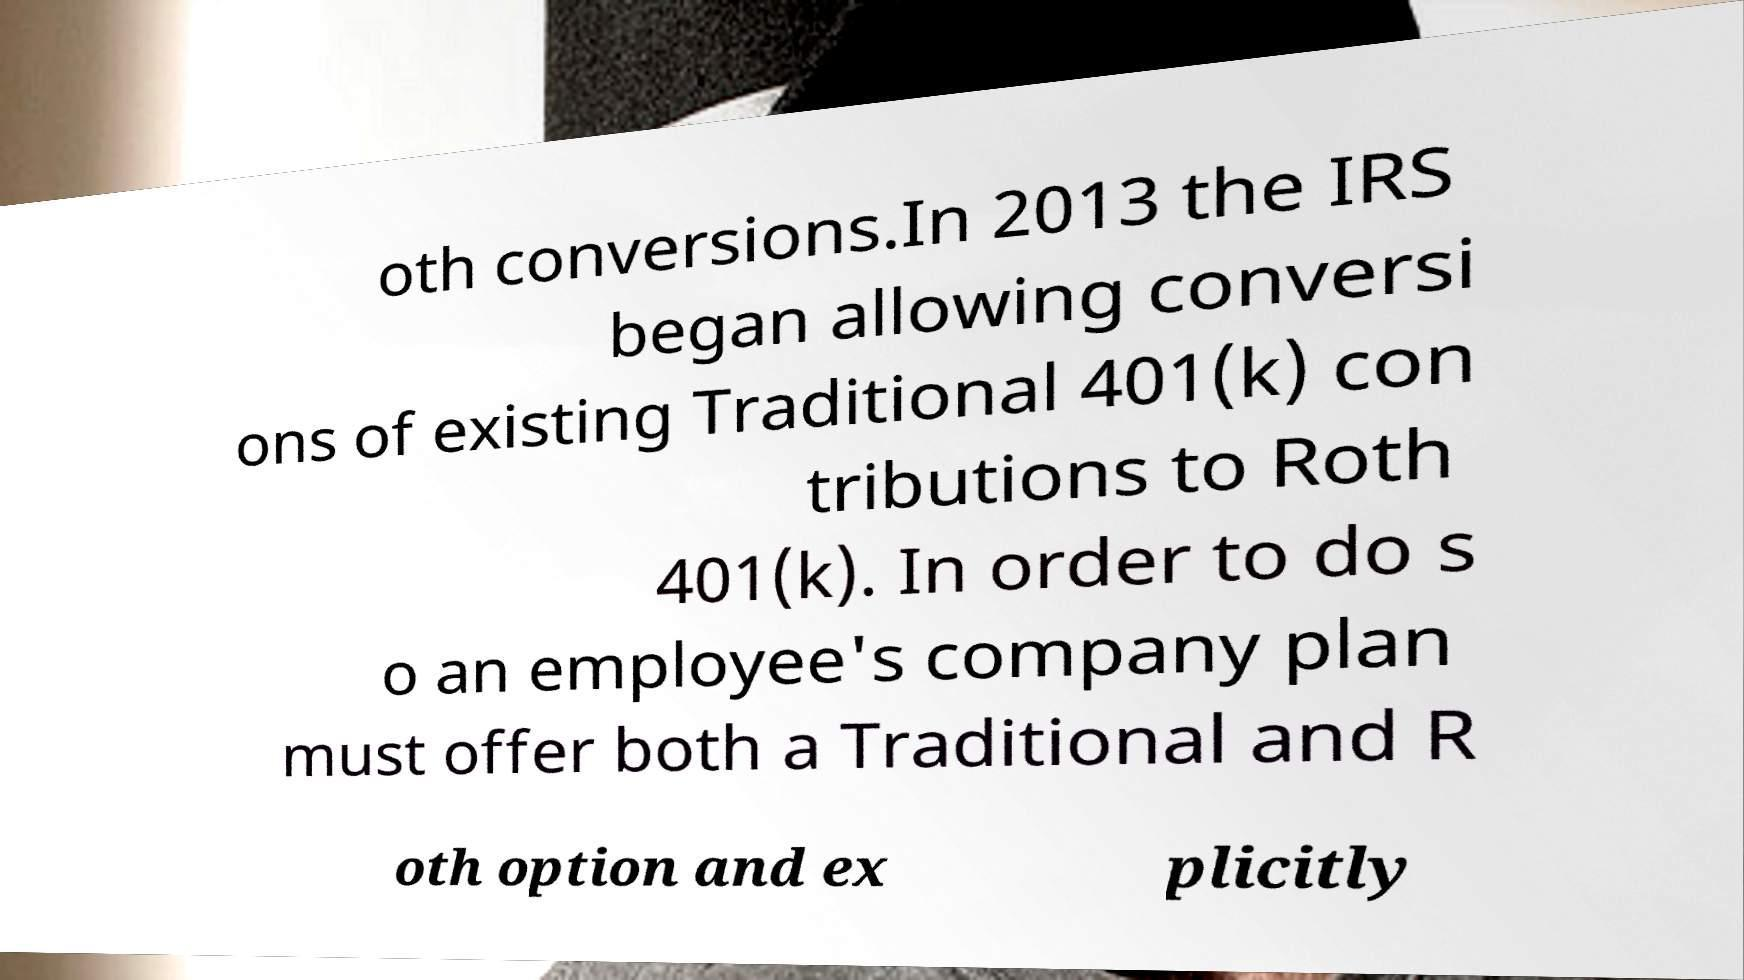I need the written content from this picture converted into text. Can you do that? oth conversions.In 2013 the IRS began allowing conversi ons of existing Traditional 401(k) con tributions to Roth 401(k). In order to do s o an employee's company plan must offer both a Traditional and R oth option and ex plicitly 